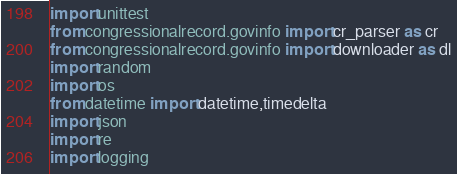<code> <loc_0><loc_0><loc_500><loc_500><_Python_>import unittest
from congressionalrecord.govinfo import cr_parser as cr
from congressionalrecord.govinfo import downloader as dl
import random
import os
from datetime import datetime,timedelta
import json
import re
import logging
</code> 